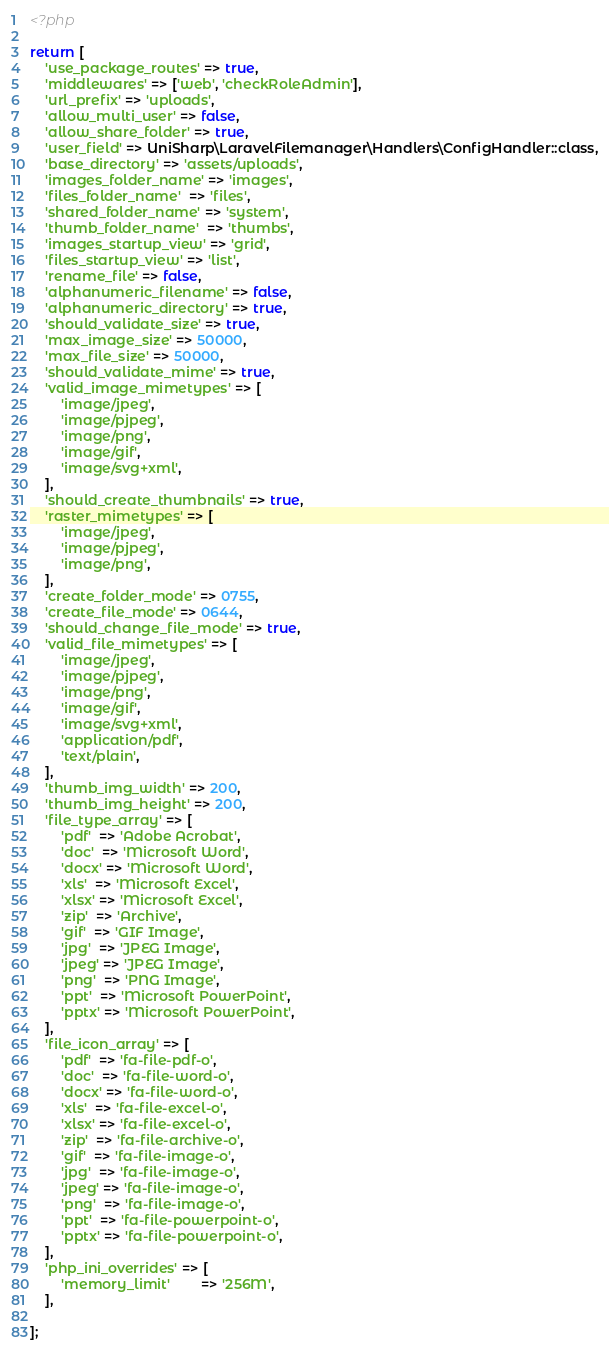Convert code to text. <code><loc_0><loc_0><loc_500><loc_500><_PHP_><?php

return [
    'use_package_routes' => true,
    'middlewares' => ['web', 'checkRoleAdmin'],
    'url_prefix' => 'uploads',
    'allow_multi_user' => false,
    'allow_share_folder' => true,
    'user_field' => UniSharp\LaravelFilemanager\Handlers\ConfigHandler::class,
    'base_directory' => 'assets/uploads',
    'images_folder_name' => 'images',
    'files_folder_name'  => 'files',
    'shared_folder_name' => 'system',
    'thumb_folder_name'  => 'thumbs',
    'images_startup_view' => 'grid',
    'files_startup_view' => 'list',
    'rename_file' => false,
    'alphanumeric_filename' => false,
    'alphanumeric_directory' => true,
    'should_validate_size' => true,
    'max_image_size' => 50000,
    'max_file_size' => 50000,
    'should_validate_mime' => true,
    'valid_image_mimetypes' => [
        'image/jpeg',
        'image/pjpeg',
        'image/png',
        'image/gif',
        'image/svg+xml',
    ],
    'should_create_thumbnails' => true,
    'raster_mimetypes' => [
        'image/jpeg',
        'image/pjpeg',
        'image/png',
    ],
    'create_folder_mode' => 0755,
    'create_file_mode' => 0644,
    'should_change_file_mode' => true,
    'valid_file_mimetypes' => [
        'image/jpeg',
        'image/pjpeg',
        'image/png',
        'image/gif',
        'image/svg+xml',
        'application/pdf',
        'text/plain',
    ],
    'thumb_img_width' => 200,
    'thumb_img_height' => 200,
    'file_type_array' => [
        'pdf'  => 'Adobe Acrobat',
        'doc'  => 'Microsoft Word',
        'docx' => 'Microsoft Word',
        'xls'  => 'Microsoft Excel',
        'xlsx' => 'Microsoft Excel',
        'zip'  => 'Archive',
        'gif'  => 'GIF Image',
        'jpg'  => 'JPEG Image',
        'jpeg' => 'JPEG Image',
        'png'  => 'PNG Image',
        'ppt'  => 'Microsoft PowerPoint',
        'pptx' => 'Microsoft PowerPoint',
    ],
    'file_icon_array' => [
        'pdf'  => 'fa-file-pdf-o',
        'doc'  => 'fa-file-word-o',
        'docx' => 'fa-file-word-o',
        'xls'  => 'fa-file-excel-o',
        'xlsx' => 'fa-file-excel-o',
        'zip'  => 'fa-file-archive-o',
        'gif'  => 'fa-file-image-o',
        'jpg'  => 'fa-file-image-o',
        'jpeg' => 'fa-file-image-o',
        'png'  => 'fa-file-image-o',
        'ppt'  => 'fa-file-powerpoint-o',
        'pptx' => 'fa-file-powerpoint-o',
    ],
    'php_ini_overrides' => [
        'memory_limit'        => '256M',
    ],

];
</code> 